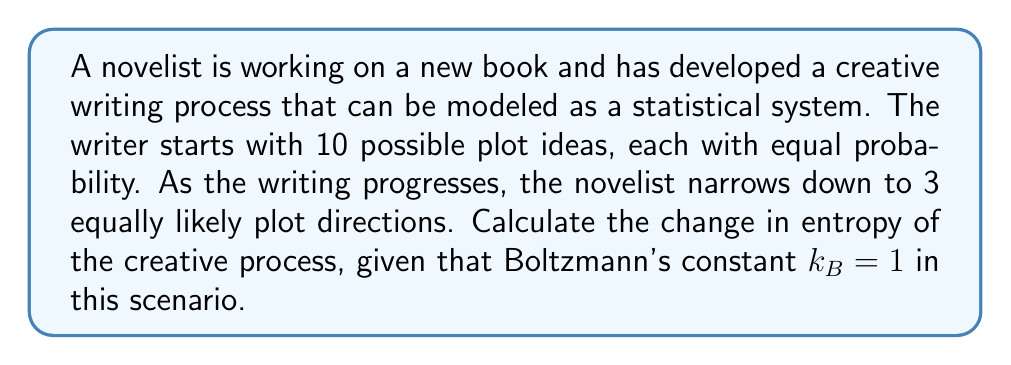Help me with this question. To solve this problem, we'll use the statistical definition of entropy and calculate the change between the initial and final states of the creative process.

1. Initial state:
   The entropy is given by $S_1 = k_B \ln W_1$, where $W_1$ is the number of microstates (plot ideas).
   $S_1 = 1 \cdot \ln 10$

2. Final state:
   The entropy is given by $S_2 = k_B \ln W_2$, where $W_2$ is the number of remaining plot directions.
   $S_2 = 1 \cdot \ln 3$

3. Calculate the change in entropy:
   $\Delta S = S_2 - S_1 = \ln 3 - \ln 10$

4. Simplify using logarithm properties:
   $\Delta S = \ln(\frac{3}{10})$

5. Calculate the numerical value:
   $\Delta S \approx -1.204$

The negative value indicates a decrease in entropy, which aligns with the narrowing of plot possibilities in the creative process.
Answer: $\Delta S = \ln(\frac{3}{10}) \approx -1.204$ 